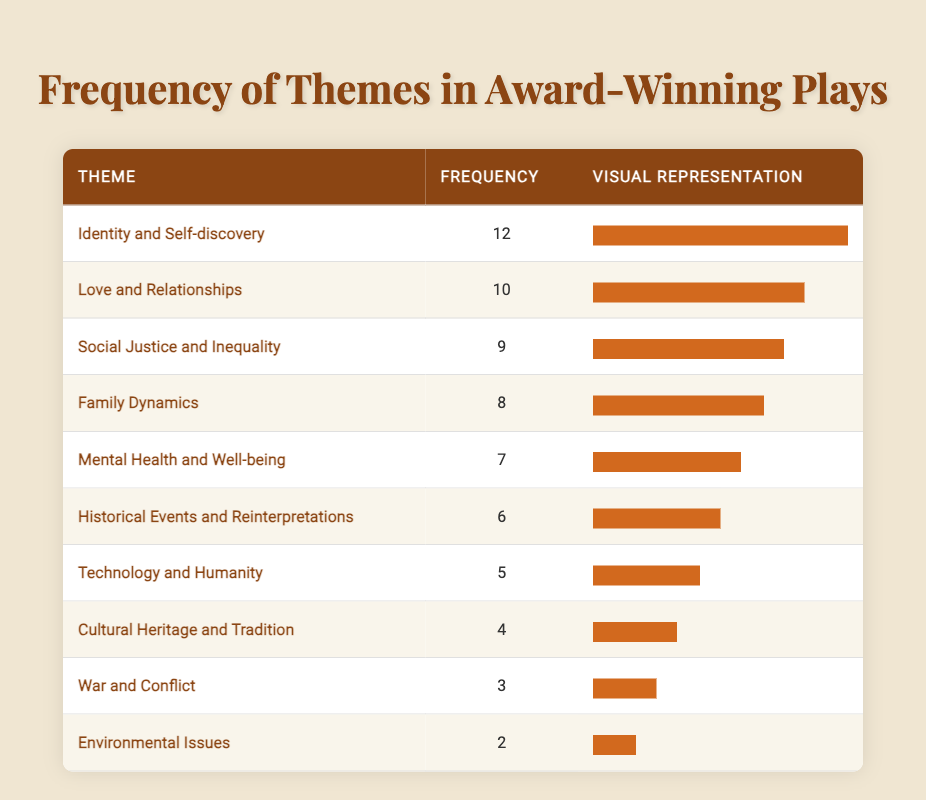What is the theme with the highest frequency in the table? The highest frequency of the themes explored in the table is 12. Referring to the first row, the theme of "Identity and Self-discovery" has the highest frequency.
Answer: Identity and Self-discovery How many themes have a frequency of 5 or more? The themes with a frequency of 5 or more are Identity and Self-discovery (12), Love and Relationships (10), Social Justice and Inequality (9), Family Dynamics (8), and Mental Health and Well-being (7). Counting these themes gives us a total of 5 themes in the specified frequency range.
Answer: 5 Is "Environmental Issues" a theme that has been explored more than "War and Conflict"? The frequency of "Environmental Issues" is 2, while "War and Conflict" has a frequency of 3. Since 2 is less than 3, it is false that "Environmental Issues" has been explored more than "War and Conflict."
Answer: No What is the total frequency of themes focusing on personal experiences (Identity and Self-discovery, Love and Relationships, Mental Health and Well-being)? We sum the frequencies of the three themes: Identity and Self-discovery (12) + Love and Relationships (10) + Mental Health and Well-being (7) = 29.
Answer: 29 Which themes, if any, have a frequency that falls exactly in the middle of the frequencies listed? To find themes in the middle, we need the median frequency value. Listing all frequencies (2, 3, 4, 5, 6, 7, 8, 9, 10, 12) yields a total of 10 values. The average of the 5th and 6th values (7 and 6) is (7 + 6) / 2 = 6.5. Hence, no theme matches this median precisely, but themes around this value are "Historical Events and Reinterpretations" (6) and "Mental Health and Well-being" (7).
Answer: No exact middle themes What percentage of the total frequency does "Cultural Heritage and Tradition" represent? First, we sum all the frequencies from the themes, which are: 12 + 9 + 8 + 7 + 10 + 6 + 5 + 4 + 3 + 2 = 66. Next, we find the frequency for "Cultural Heritage and Tradition," which is 4. The percentage is then calculated as (4 / 66) * 100 = 6.06.
Answer: 6.06% 